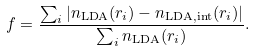Convert formula to latex. <formula><loc_0><loc_0><loc_500><loc_500>f = \frac { \sum _ { i } | n _ { \text {LDA} } ( r _ { i } ) - n _ { \text {LDA,int} } ( r _ { i } ) | } { \sum _ { i } n _ { \text {LDA} } ( r _ { i } ) } .</formula> 